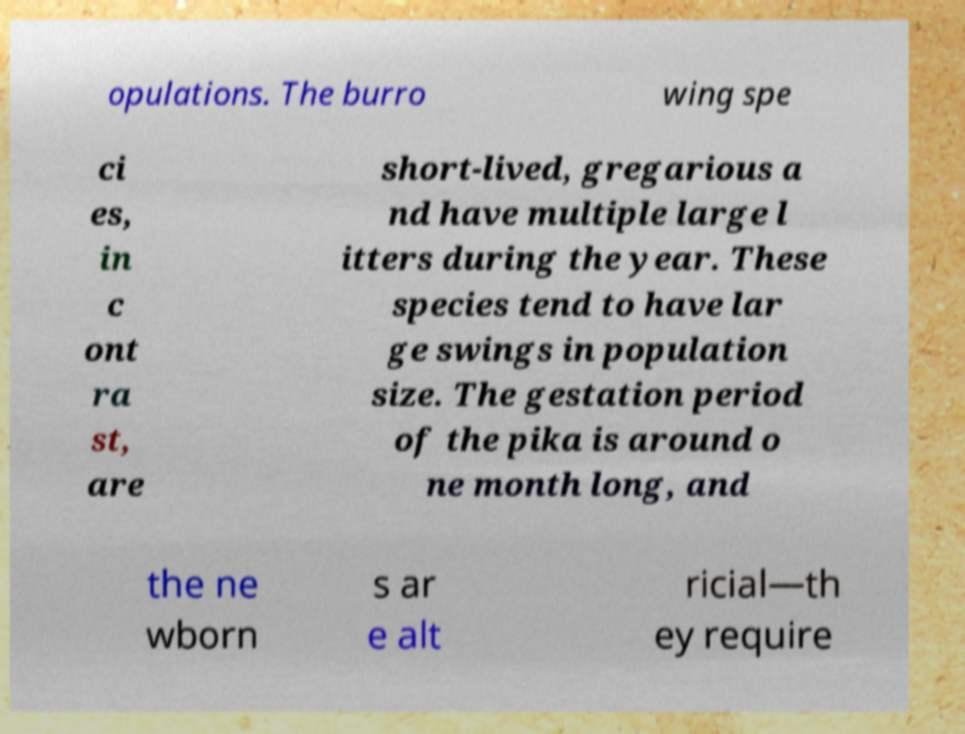There's text embedded in this image that I need extracted. Can you transcribe it verbatim? opulations. The burro wing spe ci es, in c ont ra st, are short-lived, gregarious a nd have multiple large l itters during the year. These species tend to have lar ge swings in population size. The gestation period of the pika is around o ne month long, and the ne wborn s ar e alt ricial—th ey require 